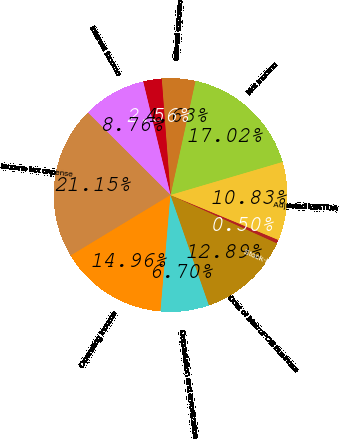<chart> <loc_0><loc_0><loc_500><loc_500><pie_chart><fcel>Net income<fcel>Interest expense<fcel>Interest expense to affiliates<fcel>Interest income<fcel>Income tax expense<fcel>Operating income<fcel>Depreciation and amortization<fcel>Cost of MetroPCS business<fcel>Stock-based compensation (1)<fcel>Adjusted EBITDA<nl><fcel>17.02%<fcel>4.63%<fcel>2.56%<fcel>8.76%<fcel>21.15%<fcel>14.96%<fcel>6.7%<fcel>12.89%<fcel>0.5%<fcel>10.83%<nl></chart> 